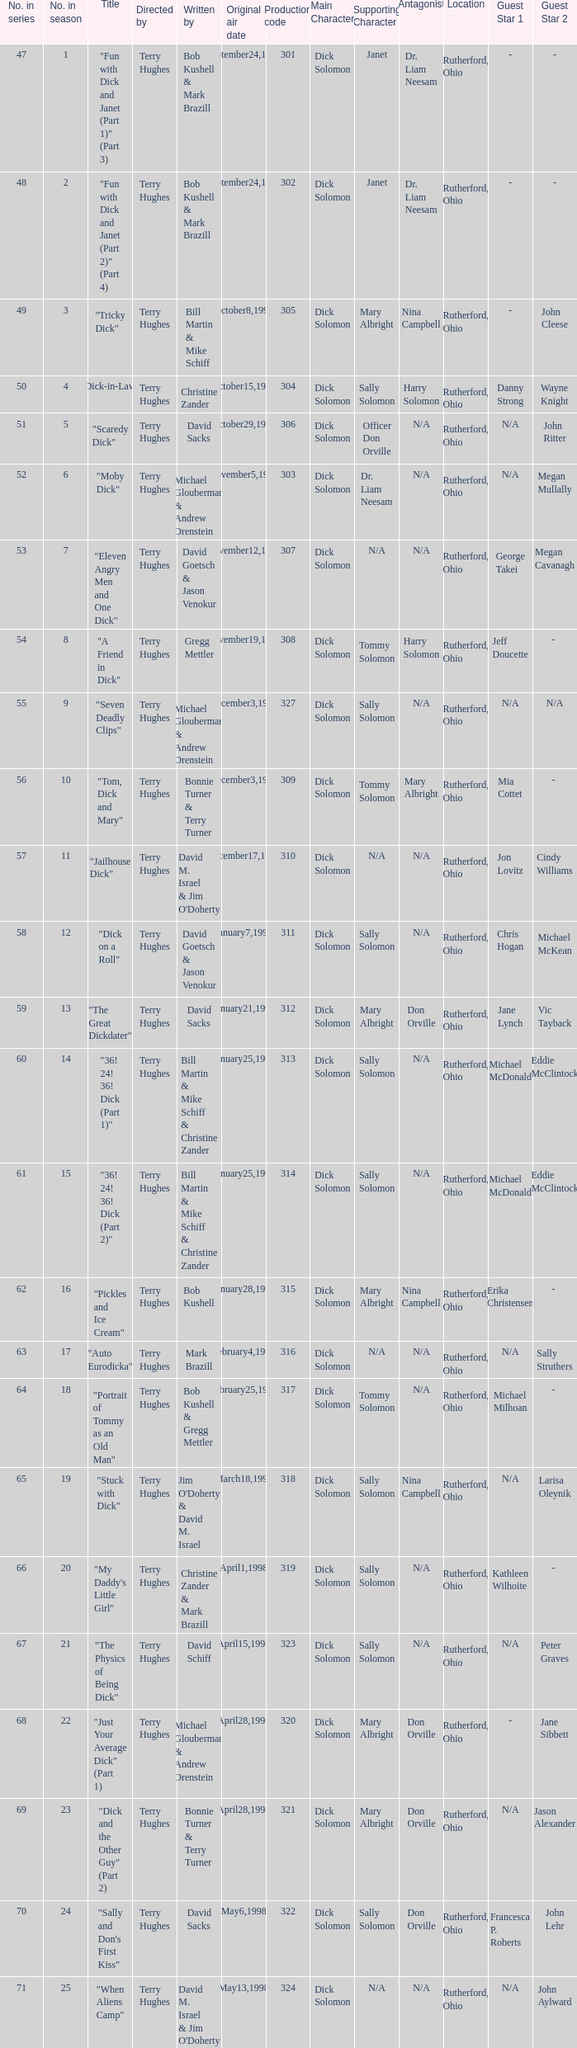What is the original air date of the episode with production code is 319? April1,1998. Can you parse all the data within this table? {'header': ['No. in series', 'No. in season', 'Title', 'Directed by', 'Written by', 'Original air date', 'Production code', 'Main Character', 'Supporting Character', 'Antagonist', 'Location', 'Guest Star 1', 'Guest Star 2'], 'rows': [['47', '1', '"Fun with Dick and Janet (Part 1)" (Part 3)', 'Terry Hughes', 'Bob Kushell & Mark Brazill', 'September24,1997', '301', 'Dick Solomon', 'Janet', 'Dr. Liam Neesam', 'Rutherford, Ohio', '-', '-'], ['48', '2', '"Fun with Dick and Janet (Part 2)" (Part 4)', 'Terry Hughes', 'Bob Kushell & Mark Brazill', 'September24,1997', '302', 'Dick Solomon', 'Janet', 'Dr. Liam Neesam', 'Rutherford, Ohio', '-', '-'], ['49', '3', '"Tricky Dick"', 'Terry Hughes', 'Bill Martin & Mike Schiff', 'October8,1997', '305', 'Dick Solomon', 'Mary Albright', 'Nina Campbell', 'Rutherford, Ohio', '-', 'John Cleese'], ['50', '4', '"Dick-in-Law"', 'Terry Hughes', 'Christine Zander', 'October15,1997', '304', 'Dick Solomon', 'Sally Solomon', 'Harry Solomon', 'Rutherford, Ohio', 'Danny Strong', 'Wayne Knight'], ['51', '5', '"Scaredy Dick"', 'Terry Hughes', 'David Sacks', 'October29,1997', '306', 'Dick Solomon', 'Officer Don Orville', 'N/A', 'Rutherford, Ohio', 'N/A', 'John Ritter'], ['52', '6', '"Moby Dick"', 'Terry Hughes', 'Michael Glouberman & Andrew Orenstein', 'November5,1997', '303', 'Dick Solomon', 'Dr. Liam Neesam', 'N/A', 'Rutherford, Ohio', 'N/A', 'Megan Mullally'], ['53', '7', '"Eleven Angry Men and One Dick"', 'Terry Hughes', 'David Goetsch & Jason Venokur', 'November12,1997', '307', 'Dick Solomon', 'N/A', 'N/A', 'Rutherford, Ohio', 'George Takei', 'Megan Cavanagh'], ['54', '8', '"A Friend in Dick"', 'Terry Hughes', 'Gregg Mettler', 'November19,1997', '308', 'Dick Solomon', 'Tommy Solomon', 'Harry Solomon', 'Rutherford, Ohio', 'Jeff Doucette', '- '], ['55', '9', '"Seven Deadly Clips"', 'Terry Hughes', 'Michael Glouberman & Andrew Orenstein', 'December3,1997', '327', 'Dick Solomon', 'Sally Solomon', 'N/A', 'Rutherford, Ohio', 'N/A', 'N/A'], ['56', '10', '"Tom, Dick and Mary"', 'Terry Hughes', 'Bonnie Turner & Terry Turner', 'December3,1997', '309', 'Dick Solomon', 'Tommy Solomon', 'Mary Albright', 'Rutherford, Ohio', 'Mia Cottet', '- '], ['57', '11', '"Jailhouse Dick"', 'Terry Hughes', "David M. Israel & Jim O'Doherty", 'December17,1997', '310', 'Dick Solomon', 'N/A', 'N/A', 'Rutherford, Ohio', 'Jon Lovitz', 'Cindy Williams'], ['58', '12', '"Dick on a Roll"', 'Terry Hughes', 'David Goetsch & Jason Venokur', 'January7,1998', '311', 'Dick Solomon', 'Sally Solomon', 'N/A', 'Rutherford, Ohio', 'Chris Hogan', 'Michael McKean'], ['59', '13', '"The Great Dickdater"', 'Terry Hughes', 'David Sacks', 'January21,1998', '312', 'Dick Solomon', 'Mary Albright', 'Don Orville', 'Rutherford, Ohio', 'Jane Lynch', 'Vic Tayback'], ['60', '14', '"36! 24! 36! Dick (Part 1)"', 'Terry Hughes', 'Bill Martin & Mike Schiff & Christine Zander', 'January25,1998', '313', 'Dick Solomon', 'Sally Solomon', 'N/A', 'Rutherford, Ohio', 'Michael McDonald', 'Eddie McClintock'], ['61', '15', '"36! 24! 36! Dick (Part 2)"', 'Terry Hughes', 'Bill Martin & Mike Schiff & Christine Zander', 'January25,1998', '314', 'Dick Solomon', 'Sally Solomon', 'N/A', 'Rutherford, Ohio', 'Michael McDonald', 'Eddie McClintock'], ['62', '16', '"Pickles and Ice Cream"', 'Terry Hughes', 'Bob Kushell', 'January28,1998', '315', 'Dick Solomon', 'Mary Albright', 'Nina Campbell', 'Rutherford, Ohio', 'Erika Christensen', '- '], ['63', '17', '"Auto Eurodicka"', 'Terry Hughes', 'Mark Brazill', 'February4,1998', '316', 'Dick Solomon', 'N/A', 'N/A', 'Rutherford, Ohio', 'N/A', 'Sally Struthers'], ['64', '18', '"Portrait of Tommy as an Old Man"', 'Terry Hughes', 'Bob Kushell & Gregg Mettler', 'February25,1998', '317', 'Dick Solomon', 'Tommy Solomon', 'N/A', 'Rutherford, Ohio', 'Michael Milhoan', '- '], ['65', '19', '"Stuck with Dick"', 'Terry Hughes', "Jim O'Doherty & David M. Israel", 'March18,1998', '318', 'Dick Solomon', 'Sally Solomon', 'Nina Campbell', 'Rutherford, Ohio', 'N/A', 'Larisa Oleynik'], ['66', '20', '"My Daddy\'s Little Girl"', 'Terry Hughes', 'Christine Zander & Mark Brazill', 'April1,1998', '319', 'Dick Solomon', 'Sally Solomon', 'N/A', 'Rutherford, Ohio', 'Kathleen Wilhoite', '- '], ['67', '21', '"The Physics of Being Dick"', 'Terry Hughes', 'David Schiff', 'April15,1998', '323', 'Dick Solomon', 'Sally Solomon', 'N/A', 'Rutherford, Ohio', 'N/A', 'Peter Graves'], ['68', '22', '"Just Your Average Dick" (Part 1)', 'Terry Hughes', 'Michael Glouberman & Andrew Orenstein', 'April28,1998', '320', 'Dick Solomon', 'Mary Albright', 'Don Orville', 'Rutherford, Ohio', '-', 'Jane Sibbett'], ['69', '23', '"Dick and the Other Guy" (Part 2)', 'Terry Hughes', 'Bonnie Turner & Terry Turner', 'April28,1998', '321', 'Dick Solomon', 'Mary Albright', 'Don Orville', 'Rutherford, Ohio', 'N/A', 'Jason Alexander'], ['70', '24', '"Sally and Don\'s First Kiss"', 'Terry Hughes', 'David Sacks', 'May6,1998', '322', 'Dick Solomon', 'Sally Solomon', 'Don Orville', 'Rutherford, Ohio', 'Francesca P. Roberts', 'John Lehr'], ['71', '25', '"When Aliens Camp"', 'Terry Hughes', "David M. Israel & Jim O'Doherty", 'May13,1998', '324', 'Dick Solomon', 'N/A', 'N/A', 'Rutherford, Ohio', 'N/A', 'John Aylward '], ['72', '26', '"The Tooth Harry"', 'Terry Hughes', 'Joshua Sternin & Jeffrey Ventimilia', 'May20,1998', '325', 'Dick Solomon', 'N/A', 'Harry Solomon', 'Rutherford, Ohio', 'N/A', '-']]} 